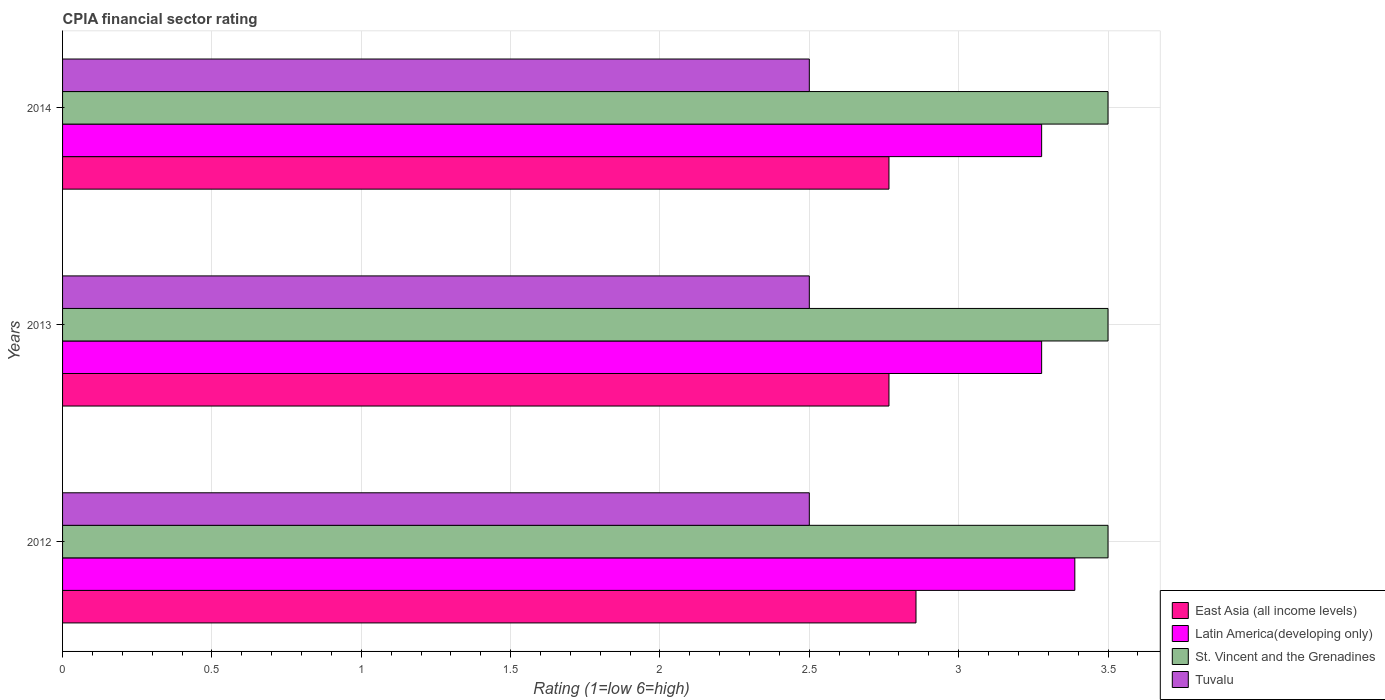How many bars are there on the 1st tick from the top?
Keep it short and to the point. 4. How many bars are there on the 2nd tick from the bottom?
Give a very brief answer. 4. What is the label of the 1st group of bars from the top?
Offer a very short reply. 2014. What is the CPIA rating in East Asia (all income levels) in 2014?
Keep it short and to the point. 2.77. Across all years, what is the maximum CPIA rating in Tuvalu?
Provide a short and direct response. 2.5. Across all years, what is the minimum CPIA rating in East Asia (all income levels)?
Provide a succinct answer. 2.77. What is the difference between the CPIA rating in East Asia (all income levels) in 2012 and that in 2013?
Make the answer very short. 0.09. What is the difference between the CPIA rating in East Asia (all income levels) in 2013 and the CPIA rating in Latin America(developing only) in 2012?
Keep it short and to the point. -0.62. What is the average CPIA rating in Latin America(developing only) per year?
Give a very brief answer. 3.31. In the year 2012, what is the difference between the CPIA rating in St. Vincent and the Grenadines and CPIA rating in Latin America(developing only)?
Your answer should be compact. 0.11. What is the ratio of the CPIA rating in St. Vincent and the Grenadines in 2012 to that in 2013?
Your response must be concise. 1. Is the CPIA rating in East Asia (all income levels) in 2012 less than that in 2014?
Provide a succinct answer. No. What is the difference between the highest and the second highest CPIA rating in Latin America(developing only)?
Offer a terse response. 0.11. What is the difference between the highest and the lowest CPIA rating in East Asia (all income levels)?
Your answer should be very brief. 0.09. In how many years, is the CPIA rating in Latin America(developing only) greater than the average CPIA rating in Latin America(developing only) taken over all years?
Make the answer very short. 1. Is it the case that in every year, the sum of the CPIA rating in East Asia (all income levels) and CPIA rating in Latin America(developing only) is greater than the sum of CPIA rating in St. Vincent and the Grenadines and CPIA rating in Tuvalu?
Offer a very short reply. No. What does the 3rd bar from the top in 2012 represents?
Keep it short and to the point. Latin America(developing only). What does the 1st bar from the bottom in 2012 represents?
Offer a terse response. East Asia (all income levels). How many bars are there?
Ensure brevity in your answer.  12. Are the values on the major ticks of X-axis written in scientific E-notation?
Your answer should be compact. No. Does the graph contain grids?
Keep it short and to the point. Yes. How many legend labels are there?
Provide a short and direct response. 4. What is the title of the graph?
Your response must be concise. CPIA financial sector rating. What is the label or title of the X-axis?
Your response must be concise. Rating (1=low 6=high). What is the Rating (1=low 6=high) of East Asia (all income levels) in 2012?
Your response must be concise. 2.86. What is the Rating (1=low 6=high) of Latin America(developing only) in 2012?
Provide a succinct answer. 3.39. What is the Rating (1=low 6=high) of East Asia (all income levels) in 2013?
Your answer should be very brief. 2.77. What is the Rating (1=low 6=high) of Latin America(developing only) in 2013?
Your answer should be compact. 3.28. What is the Rating (1=low 6=high) in St. Vincent and the Grenadines in 2013?
Keep it short and to the point. 3.5. What is the Rating (1=low 6=high) of Tuvalu in 2013?
Your answer should be compact. 2.5. What is the Rating (1=low 6=high) in East Asia (all income levels) in 2014?
Your answer should be compact. 2.77. What is the Rating (1=low 6=high) in Latin America(developing only) in 2014?
Your answer should be compact. 3.28. What is the Rating (1=low 6=high) of St. Vincent and the Grenadines in 2014?
Ensure brevity in your answer.  3.5. Across all years, what is the maximum Rating (1=low 6=high) in East Asia (all income levels)?
Ensure brevity in your answer.  2.86. Across all years, what is the maximum Rating (1=low 6=high) in Latin America(developing only)?
Provide a short and direct response. 3.39. Across all years, what is the maximum Rating (1=low 6=high) in St. Vincent and the Grenadines?
Offer a terse response. 3.5. Across all years, what is the minimum Rating (1=low 6=high) of East Asia (all income levels)?
Your answer should be very brief. 2.77. Across all years, what is the minimum Rating (1=low 6=high) in Latin America(developing only)?
Offer a terse response. 3.28. Across all years, what is the minimum Rating (1=low 6=high) in St. Vincent and the Grenadines?
Offer a very short reply. 3.5. Across all years, what is the minimum Rating (1=low 6=high) of Tuvalu?
Provide a succinct answer. 2.5. What is the total Rating (1=low 6=high) of East Asia (all income levels) in the graph?
Offer a terse response. 8.39. What is the total Rating (1=low 6=high) in Latin America(developing only) in the graph?
Offer a terse response. 9.94. What is the total Rating (1=low 6=high) of Tuvalu in the graph?
Make the answer very short. 7.5. What is the difference between the Rating (1=low 6=high) of East Asia (all income levels) in 2012 and that in 2013?
Give a very brief answer. 0.09. What is the difference between the Rating (1=low 6=high) of St. Vincent and the Grenadines in 2012 and that in 2013?
Ensure brevity in your answer.  0. What is the difference between the Rating (1=low 6=high) in Tuvalu in 2012 and that in 2013?
Your answer should be compact. 0. What is the difference between the Rating (1=low 6=high) of East Asia (all income levels) in 2012 and that in 2014?
Offer a very short reply. 0.09. What is the difference between the Rating (1=low 6=high) in Latin America(developing only) in 2012 and that in 2014?
Your response must be concise. 0.11. What is the difference between the Rating (1=low 6=high) in St. Vincent and the Grenadines in 2012 and that in 2014?
Offer a very short reply. 0. What is the difference between the Rating (1=low 6=high) in East Asia (all income levels) in 2013 and that in 2014?
Provide a short and direct response. 0. What is the difference between the Rating (1=low 6=high) of St. Vincent and the Grenadines in 2013 and that in 2014?
Your answer should be very brief. 0. What is the difference between the Rating (1=low 6=high) in Tuvalu in 2013 and that in 2014?
Your answer should be compact. 0. What is the difference between the Rating (1=low 6=high) of East Asia (all income levels) in 2012 and the Rating (1=low 6=high) of Latin America(developing only) in 2013?
Keep it short and to the point. -0.42. What is the difference between the Rating (1=low 6=high) of East Asia (all income levels) in 2012 and the Rating (1=low 6=high) of St. Vincent and the Grenadines in 2013?
Your response must be concise. -0.64. What is the difference between the Rating (1=low 6=high) of East Asia (all income levels) in 2012 and the Rating (1=low 6=high) of Tuvalu in 2013?
Offer a terse response. 0.36. What is the difference between the Rating (1=low 6=high) in Latin America(developing only) in 2012 and the Rating (1=low 6=high) in St. Vincent and the Grenadines in 2013?
Give a very brief answer. -0.11. What is the difference between the Rating (1=low 6=high) of St. Vincent and the Grenadines in 2012 and the Rating (1=low 6=high) of Tuvalu in 2013?
Provide a short and direct response. 1. What is the difference between the Rating (1=low 6=high) of East Asia (all income levels) in 2012 and the Rating (1=low 6=high) of Latin America(developing only) in 2014?
Your answer should be compact. -0.42. What is the difference between the Rating (1=low 6=high) in East Asia (all income levels) in 2012 and the Rating (1=low 6=high) in St. Vincent and the Grenadines in 2014?
Your response must be concise. -0.64. What is the difference between the Rating (1=low 6=high) in East Asia (all income levels) in 2012 and the Rating (1=low 6=high) in Tuvalu in 2014?
Keep it short and to the point. 0.36. What is the difference between the Rating (1=low 6=high) of Latin America(developing only) in 2012 and the Rating (1=low 6=high) of St. Vincent and the Grenadines in 2014?
Offer a terse response. -0.11. What is the difference between the Rating (1=low 6=high) in East Asia (all income levels) in 2013 and the Rating (1=low 6=high) in Latin America(developing only) in 2014?
Make the answer very short. -0.51. What is the difference between the Rating (1=low 6=high) in East Asia (all income levels) in 2013 and the Rating (1=low 6=high) in St. Vincent and the Grenadines in 2014?
Offer a very short reply. -0.73. What is the difference between the Rating (1=low 6=high) of East Asia (all income levels) in 2013 and the Rating (1=low 6=high) of Tuvalu in 2014?
Make the answer very short. 0.27. What is the difference between the Rating (1=low 6=high) in Latin America(developing only) in 2013 and the Rating (1=low 6=high) in St. Vincent and the Grenadines in 2014?
Provide a short and direct response. -0.22. What is the difference between the Rating (1=low 6=high) in St. Vincent and the Grenadines in 2013 and the Rating (1=low 6=high) in Tuvalu in 2014?
Ensure brevity in your answer.  1. What is the average Rating (1=low 6=high) of East Asia (all income levels) per year?
Your answer should be very brief. 2.8. What is the average Rating (1=low 6=high) in Latin America(developing only) per year?
Offer a terse response. 3.31. What is the average Rating (1=low 6=high) of Tuvalu per year?
Your answer should be compact. 2.5. In the year 2012, what is the difference between the Rating (1=low 6=high) of East Asia (all income levels) and Rating (1=low 6=high) of Latin America(developing only)?
Give a very brief answer. -0.53. In the year 2012, what is the difference between the Rating (1=low 6=high) of East Asia (all income levels) and Rating (1=low 6=high) of St. Vincent and the Grenadines?
Give a very brief answer. -0.64. In the year 2012, what is the difference between the Rating (1=low 6=high) of East Asia (all income levels) and Rating (1=low 6=high) of Tuvalu?
Provide a short and direct response. 0.36. In the year 2012, what is the difference between the Rating (1=low 6=high) of Latin America(developing only) and Rating (1=low 6=high) of St. Vincent and the Grenadines?
Give a very brief answer. -0.11. In the year 2012, what is the difference between the Rating (1=low 6=high) in Latin America(developing only) and Rating (1=low 6=high) in Tuvalu?
Keep it short and to the point. 0.89. In the year 2012, what is the difference between the Rating (1=low 6=high) in St. Vincent and the Grenadines and Rating (1=low 6=high) in Tuvalu?
Provide a succinct answer. 1. In the year 2013, what is the difference between the Rating (1=low 6=high) in East Asia (all income levels) and Rating (1=low 6=high) in Latin America(developing only)?
Give a very brief answer. -0.51. In the year 2013, what is the difference between the Rating (1=low 6=high) in East Asia (all income levels) and Rating (1=low 6=high) in St. Vincent and the Grenadines?
Give a very brief answer. -0.73. In the year 2013, what is the difference between the Rating (1=low 6=high) in East Asia (all income levels) and Rating (1=low 6=high) in Tuvalu?
Provide a succinct answer. 0.27. In the year 2013, what is the difference between the Rating (1=low 6=high) of Latin America(developing only) and Rating (1=low 6=high) of St. Vincent and the Grenadines?
Ensure brevity in your answer.  -0.22. In the year 2013, what is the difference between the Rating (1=low 6=high) in Latin America(developing only) and Rating (1=low 6=high) in Tuvalu?
Provide a short and direct response. 0.78. In the year 2013, what is the difference between the Rating (1=low 6=high) in St. Vincent and the Grenadines and Rating (1=low 6=high) in Tuvalu?
Ensure brevity in your answer.  1. In the year 2014, what is the difference between the Rating (1=low 6=high) in East Asia (all income levels) and Rating (1=low 6=high) in Latin America(developing only)?
Give a very brief answer. -0.51. In the year 2014, what is the difference between the Rating (1=low 6=high) in East Asia (all income levels) and Rating (1=low 6=high) in St. Vincent and the Grenadines?
Provide a short and direct response. -0.73. In the year 2014, what is the difference between the Rating (1=low 6=high) of East Asia (all income levels) and Rating (1=low 6=high) of Tuvalu?
Keep it short and to the point. 0.27. In the year 2014, what is the difference between the Rating (1=low 6=high) of Latin America(developing only) and Rating (1=low 6=high) of St. Vincent and the Grenadines?
Offer a very short reply. -0.22. In the year 2014, what is the difference between the Rating (1=low 6=high) of St. Vincent and the Grenadines and Rating (1=low 6=high) of Tuvalu?
Your answer should be very brief. 1. What is the ratio of the Rating (1=low 6=high) of East Asia (all income levels) in 2012 to that in 2013?
Your response must be concise. 1.03. What is the ratio of the Rating (1=low 6=high) in Latin America(developing only) in 2012 to that in 2013?
Keep it short and to the point. 1.03. What is the ratio of the Rating (1=low 6=high) of St. Vincent and the Grenadines in 2012 to that in 2013?
Provide a succinct answer. 1. What is the ratio of the Rating (1=low 6=high) in East Asia (all income levels) in 2012 to that in 2014?
Keep it short and to the point. 1.03. What is the ratio of the Rating (1=low 6=high) of Latin America(developing only) in 2012 to that in 2014?
Offer a terse response. 1.03. What is the ratio of the Rating (1=low 6=high) of St. Vincent and the Grenadines in 2012 to that in 2014?
Offer a terse response. 1. What is the ratio of the Rating (1=low 6=high) in East Asia (all income levels) in 2013 to that in 2014?
Provide a short and direct response. 1. What is the ratio of the Rating (1=low 6=high) of Latin America(developing only) in 2013 to that in 2014?
Keep it short and to the point. 1. What is the difference between the highest and the second highest Rating (1=low 6=high) of East Asia (all income levels)?
Ensure brevity in your answer.  0.09. What is the difference between the highest and the lowest Rating (1=low 6=high) of East Asia (all income levels)?
Provide a succinct answer. 0.09. What is the difference between the highest and the lowest Rating (1=low 6=high) in St. Vincent and the Grenadines?
Your response must be concise. 0. What is the difference between the highest and the lowest Rating (1=low 6=high) in Tuvalu?
Offer a very short reply. 0. 